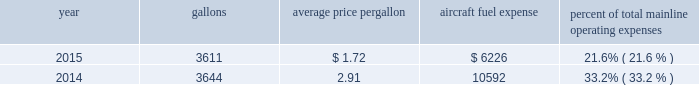Table of contents certain union-represented american mainline employees are covered by agreements that are not currently amendable .
Until those agreements become amendable , negotiations for jcbas will be conducted outside the traditional rla bargaining process described above , and , in the meantime , no self-help will be permissible .
The piedmont mechanics and stock clerks and the psa dispatchers have agreements that are now amendable and are engaged in traditional rla negotiations .
None of the unions representing our employees presently may lawfully engage in concerted refusals to work , such as strikes , slow-downs , sick-outs or other similar activity , against us .
Nonetheless , there is a risk that disgruntled employees , either with or without union involvement , could engage in one or more concerted refusals to work that could individually or collectively harm the operation of our airline and impair our financial performance .
For more discussion , see part i , item 1a .
Risk factors 2013 201cunion disputes , employee strikes and other labor-related disruptions may adversely affect our operations . 201d aircraft fuel our operations and financial results are significantly affected by the availability and price of jet fuel .
Based on our 2016 forecasted mainline and regional fuel consumption , we estimate that , as of december 31 , 2015 , a one cent per gallon increase in aviation fuel price would increase our 2016 annual fuel expense by $ 44 million .
The table shows annual aircraft fuel consumption and costs , including taxes , for our mainline operations for 2015 and 2014 ( gallons and aircraft fuel expense in millions ) .
Year gallons average price per gallon aircraft fuel expense percent of total mainline operating expenses .
Total fuel expenses for our wholly-owned and third-party regional carriers operating under capacity purchase agreements of american were $ 1.2 billion and $ 2.0 billion for the years ended december 31 , 2015 and 2014 , respectively .
As of december 31 , 2015 , we did not have any fuel hedging contracts outstanding to hedge our fuel consumption .
As such , and assuming we do not enter into any future transactions to hedge our fuel consumption , we will continue to be fully exposed to fluctuations in fuel prices .
Our current policy is not to enter into transactions to hedge our fuel consumption , although we review that policy from time to time based on market conditions and other factors .
Fuel prices have fluctuated substantially over the past several years .
We cannot predict the future availability , price volatility or cost of aircraft fuel .
Natural disasters , political disruptions or wars involving oil-producing countries , changes in fuel-related governmental policy , the strength of the u.s .
Dollar against foreign currencies , changes in access to petroleum product pipelines and terminals , speculation in the energy futures markets , changes in aircraft fuel production capacity , environmental concerns and other unpredictable events may result in fuel supply shortages , additional fuel price volatility and cost increases in the future .
See part i , item 1a .
Risk factors 2013 201cour business is dependent on the price and availability of aircraft fuel .
Continued periods of high volatility in fuel costs , increased fuel prices and significant disruptions in the supply of aircraft fuel could have a significant negative impact on our operating results and liquidity . 201d insurance we maintain insurance of the types that we believe are customary in the airline industry , including insurance for public liability , passenger liability , property damage , and all-risk coverage for damage to our aircraft .
Principal coverage includes liability for injury to members of the public , including passengers , damage to .
In 2016 what is the anticipated percentage increase in the aircraft fuel expense? 
Rationale: based on the projection of a one cent increase in 2016 it is anticipated to lead to 0.71% increase in the aircraft fuel expense
Computations: (44 / 6226)
Answer: 0.00707. 